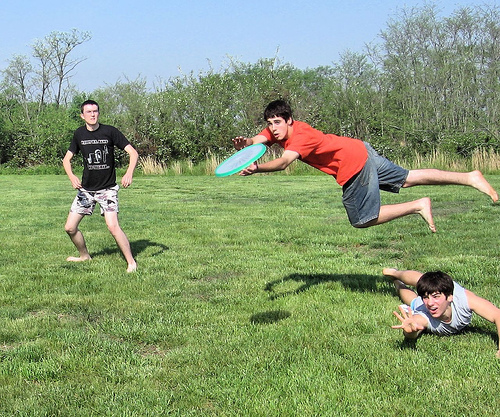Please provide a short description for this region: [0.43, 0.34, 0.55, 0.45]. A boy catching a frisbee with his hands outstretched. 